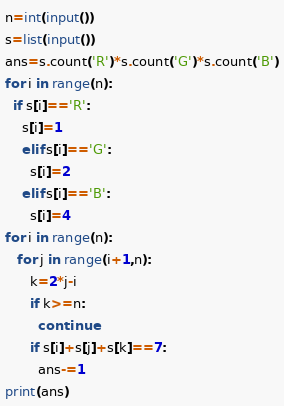Convert code to text. <code><loc_0><loc_0><loc_500><loc_500><_Python_>n=int(input())
s=list(input())
ans=s.count('R')*s.count('G')*s.count('B')
for i in range(n):
  if s[i]=='R':
    s[i]=1
    elif s[i]=='G':
      s[i]=2
    elif s[i]=='B':
      s[i]=4
for i in range(n):
   for j in range(i+1,n):
      k=2*j-i
      if k>=n:
        continue
      if s[i]+s[j]+s[k]==7:
        ans-=1
print(ans)
</code> 